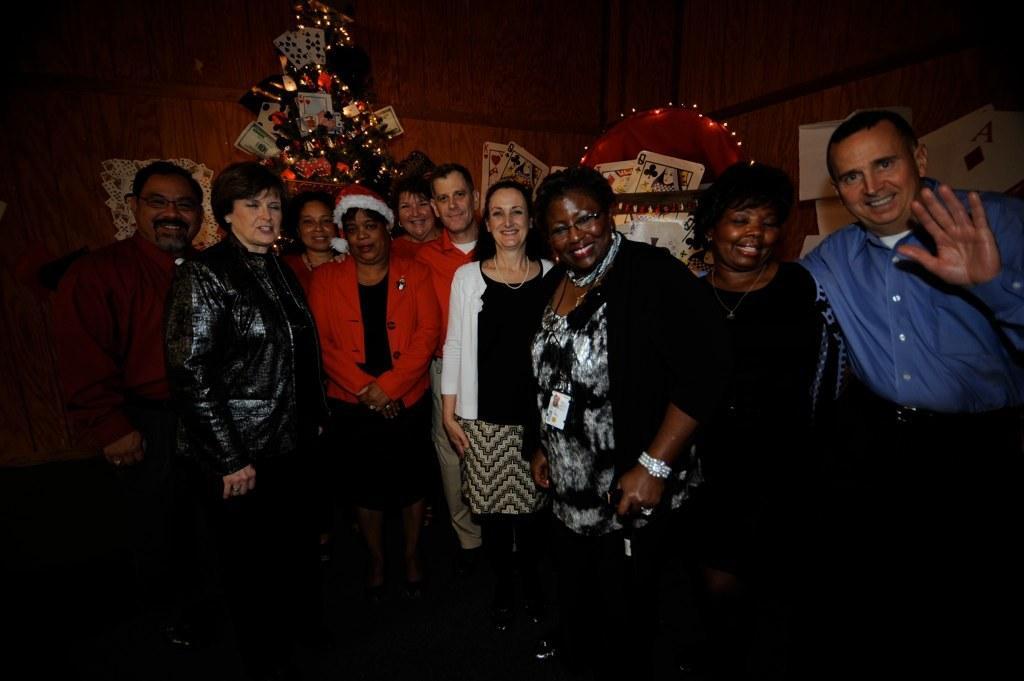Please provide a concise description of this image. In this image I can see number of people with smile on their faces. In the background I can see a Christmas tree with decoration of cards and lights. 